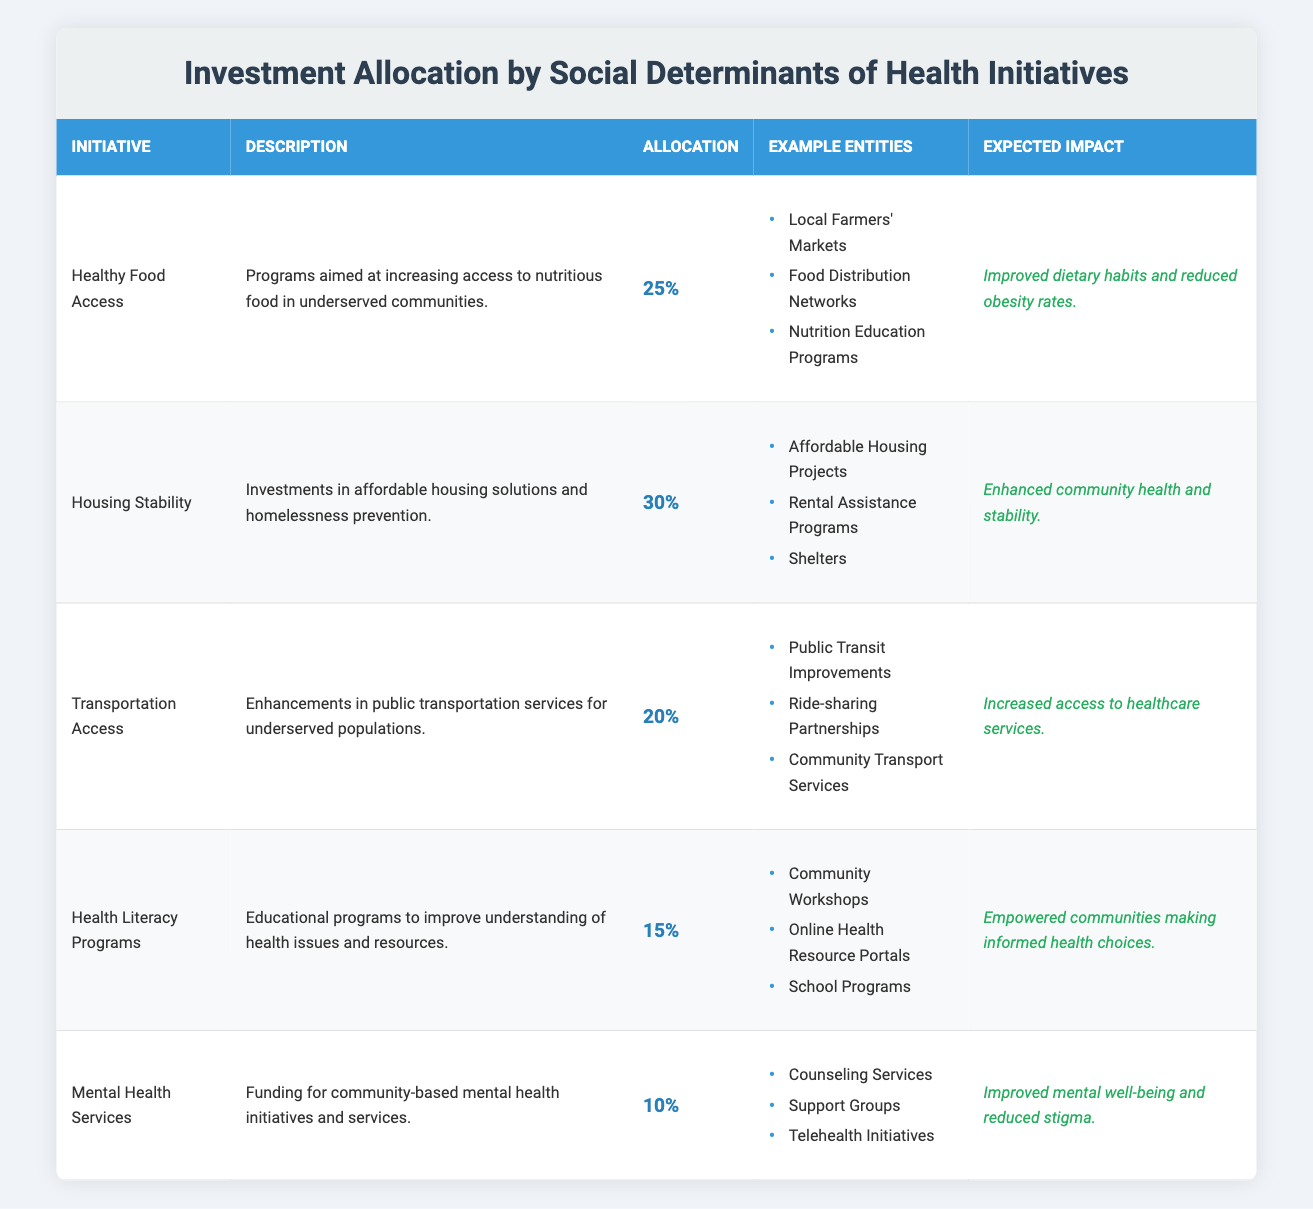What is the total percentage allocation for Healthy Food Access and Transportation Access? The percentage allocation for Healthy Food Access is 25% and for Transportation Access is 20%. Adding these two values together gives us 25% + 20% = 45%.
Answer: 45% Which initiative has the highest percentage allocation? The initiative with the highest percentage allocation is Housing Stability, which has an allocation of 30%.
Answer: Housing Stability Is funding for Mental Health Services less than that for Health Literacy Programs? Mental Health Services has a percentage allocation of 10%, while Health Literacy Programs has an allocation of 15%. Since 10% is less than 15%, this statement is true.
Answer: Yes What is the expected impact of Transportation Access initiatives? The expected impact of Transportation Access initiatives is increased access to healthcare services, as stated in the table.
Answer: Increased access to healthcare services What percentage of the total investment allocation is dedicated to initiatives related to Health Literacy Programs and Mental Health Services combined? Health Literacy Programs allocate 15% and Mental Health Services allocate 10%. Adding these two percentages gives 15% + 10% = 25%.
Answer: 25% Are there more example entities listed under Housing Stability than under Healthy Food Access? Housing Stability has three example entities, while Healthy Food Access also has three example entities listed. Therefore, they are equal in number, making the answer false.
Answer: No If the total investment is $1,000,000, how much is allocated to Healthy Food Access? The percentage allocation for Healthy Food Access is 25%. To find the allocation, multiply 1,000,000 by 25% which is 1,000,000 * 0.25 = 250,000.
Answer: $250,000 What are the main focus areas of the initiatives listed in the table? The focus areas include food access, housing stability, transportation access, health literacy, and mental health services as outlined in the initiative descriptions.
Answer: Food access, housing stability, transportation access, health literacy, mental health services Which initiative has the least expected impact? The initiative with the least expected impact is Mental Health Services, with an expected outcome of improved mental well-being and reduced stigma, which is less quantifiable compared to the more direct impacts of other initiatives.
Answer: Mental Health Services 